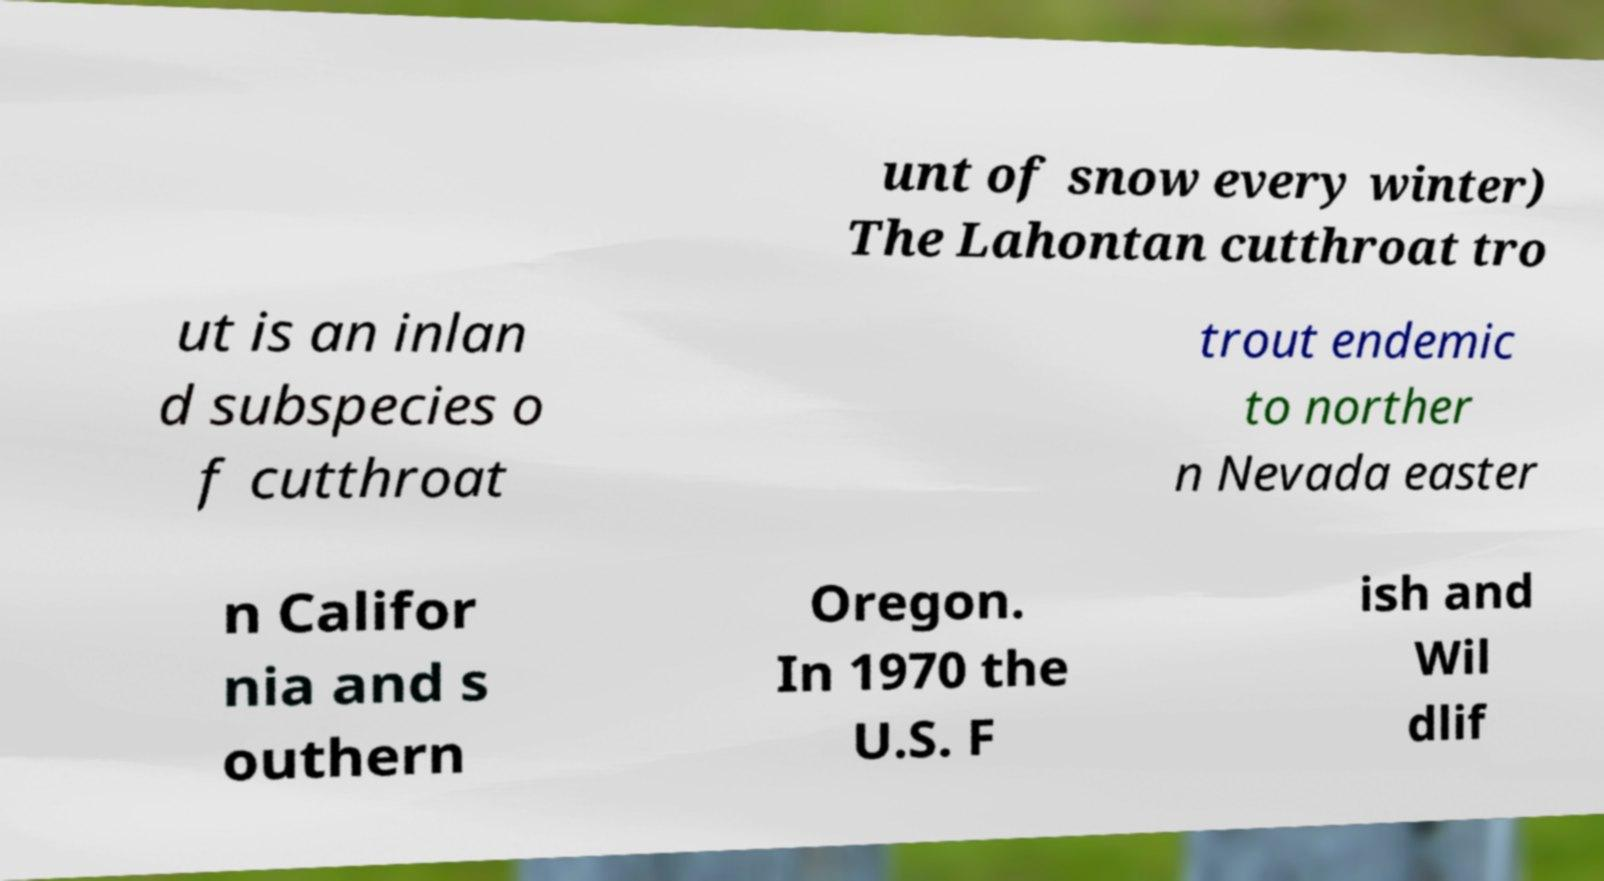Please read and relay the text visible in this image. What does it say? unt of snow every winter) The Lahontan cutthroat tro ut is an inlan d subspecies o f cutthroat trout endemic to norther n Nevada easter n Califor nia and s outhern Oregon. In 1970 the U.S. F ish and Wil dlif 